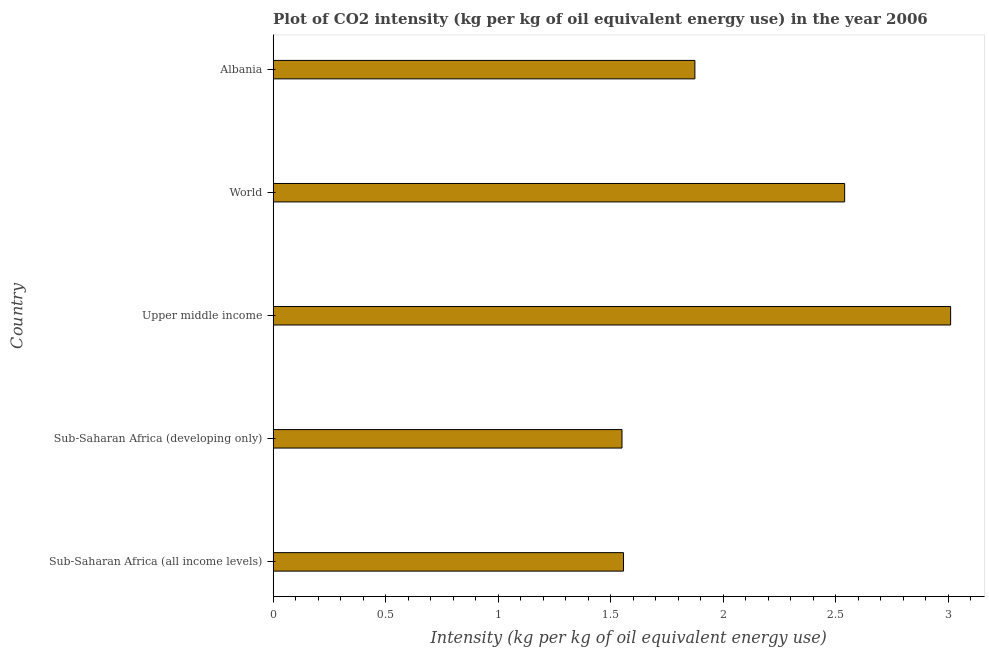Does the graph contain grids?
Offer a terse response. No. What is the title of the graph?
Ensure brevity in your answer.  Plot of CO2 intensity (kg per kg of oil equivalent energy use) in the year 2006. What is the label or title of the X-axis?
Keep it short and to the point. Intensity (kg per kg of oil equivalent energy use). What is the co2 intensity in Upper middle income?
Provide a succinct answer. 3.01. Across all countries, what is the maximum co2 intensity?
Your response must be concise. 3.01. Across all countries, what is the minimum co2 intensity?
Provide a short and direct response. 1.55. In which country was the co2 intensity maximum?
Ensure brevity in your answer.  Upper middle income. In which country was the co2 intensity minimum?
Give a very brief answer. Sub-Saharan Africa (developing only). What is the sum of the co2 intensity?
Provide a succinct answer. 10.53. What is the difference between the co2 intensity in Upper middle income and World?
Make the answer very short. 0.47. What is the average co2 intensity per country?
Give a very brief answer. 2.11. What is the median co2 intensity?
Ensure brevity in your answer.  1.87. What is the ratio of the co2 intensity in Sub-Saharan Africa (developing only) to that in World?
Keep it short and to the point. 0.61. Is the co2 intensity in Sub-Saharan Africa (developing only) less than that in World?
Offer a very short reply. Yes. Is the difference between the co2 intensity in Sub-Saharan Africa (all income levels) and Sub-Saharan Africa (developing only) greater than the difference between any two countries?
Offer a terse response. No. What is the difference between the highest and the second highest co2 intensity?
Your answer should be compact. 0.47. Is the sum of the co2 intensity in Sub-Saharan Africa (developing only) and World greater than the maximum co2 intensity across all countries?
Provide a succinct answer. Yes. What is the difference between the highest and the lowest co2 intensity?
Your answer should be compact. 1.46. In how many countries, is the co2 intensity greater than the average co2 intensity taken over all countries?
Ensure brevity in your answer.  2. How many bars are there?
Ensure brevity in your answer.  5. Are all the bars in the graph horizontal?
Ensure brevity in your answer.  Yes. What is the difference between two consecutive major ticks on the X-axis?
Your answer should be very brief. 0.5. Are the values on the major ticks of X-axis written in scientific E-notation?
Make the answer very short. No. What is the Intensity (kg per kg of oil equivalent energy use) of Sub-Saharan Africa (all income levels)?
Make the answer very short. 1.56. What is the Intensity (kg per kg of oil equivalent energy use) in Sub-Saharan Africa (developing only)?
Make the answer very short. 1.55. What is the Intensity (kg per kg of oil equivalent energy use) of Upper middle income?
Offer a very short reply. 3.01. What is the Intensity (kg per kg of oil equivalent energy use) in World?
Your answer should be compact. 2.54. What is the Intensity (kg per kg of oil equivalent energy use) in Albania?
Offer a terse response. 1.87. What is the difference between the Intensity (kg per kg of oil equivalent energy use) in Sub-Saharan Africa (all income levels) and Sub-Saharan Africa (developing only)?
Make the answer very short. 0.01. What is the difference between the Intensity (kg per kg of oil equivalent energy use) in Sub-Saharan Africa (all income levels) and Upper middle income?
Keep it short and to the point. -1.45. What is the difference between the Intensity (kg per kg of oil equivalent energy use) in Sub-Saharan Africa (all income levels) and World?
Make the answer very short. -0.98. What is the difference between the Intensity (kg per kg of oil equivalent energy use) in Sub-Saharan Africa (all income levels) and Albania?
Make the answer very short. -0.32. What is the difference between the Intensity (kg per kg of oil equivalent energy use) in Sub-Saharan Africa (developing only) and Upper middle income?
Your answer should be compact. -1.46. What is the difference between the Intensity (kg per kg of oil equivalent energy use) in Sub-Saharan Africa (developing only) and World?
Offer a terse response. -0.99. What is the difference between the Intensity (kg per kg of oil equivalent energy use) in Sub-Saharan Africa (developing only) and Albania?
Your answer should be very brief. -0.32. What is the difference between the Intensity (kg per kg of oil equivalent energy use) in Upper middle income and World?
Provide a short and direct response. 0.47. What is the difference between the Intensity (kg per kg of oil equivalent energy use) in Upper middle income and Albania?
Your answer should be very brief. 1.14. What is the difference between the Intensity (kg per kg of oil equivalent energy use) in World and Albania?
Your answer should be very brief. 0.67. What is the ratio of the Intensity (kg per kg of oil equivalent energy use) in Sub-Saharan Africa (all income levels) to that in Upper middle income?
Provide a succinct answer. 0.52. What is the ratio of the Intensity (kg per kg of oil equivalent energy use) in Sub-Saharan Africa (all income levels) to that in World?
Make the answer very short. 0.61. What is the ratio of the Intensity (kg per kg of oil equivalent energy use) in Sub-Saharan Africa (all income levels) to that in Albania?
Provide a short and direct response. 0.83. What is the ratio of the Intensity (kg per kg of oil equivalent energy use) in Sub-Saharan Africa (developing only) to that in Upper middle income?
Ensure brevity in your answer.  0.52. What is the ratio of the Intensity (kg per kg of oil equivalent energy use) in Sub-Saharan Africa (developing only) to that in World?
Give a very brief answer. 0.61. What is the ratio of the Intensity (kg per kg of oil equivalent energy use) in Sub-Saharan Africa (developing only) to that in Albania?
Your answer should be very brief. 0.83. What is the ratio of the Intensity (kg per kg of oil equivalent energy use) in Upper middle income to that in World?
Ensure brevity in your answer.  1.19. What is the ratio of the Intensity (kg per kg of oil equivalent energy use) in Upper middle income to that in Albania?
Make the answer very short. 1.61. What is the ratio of the Intensity (kg per kg of oil equivalent energy use) in World to that in Albania?
Give a very brief answer. 1.35. 